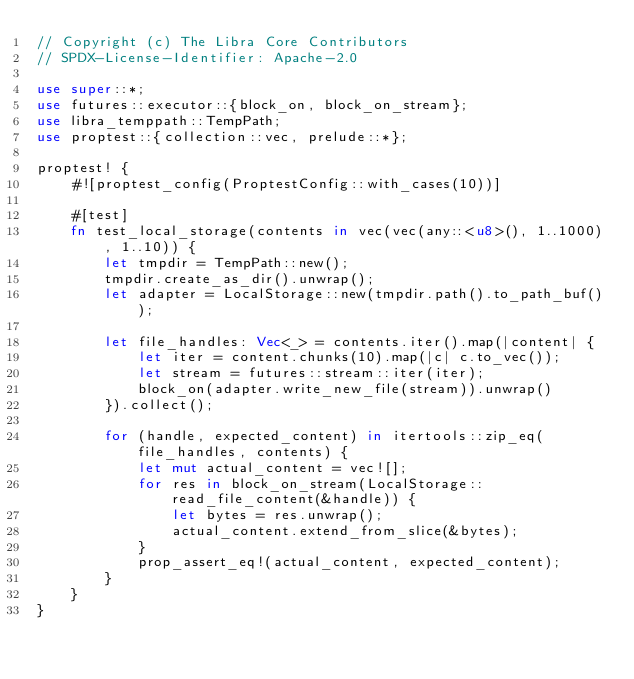Convert code to text. <code><loc_0><loc_0><loc_500><loc_500><_Rust_>// Copyright (c) The Libra Core Contributors
// SPDX-License-Identifier: Apache-2.0

use super::*;
use futures::executor::{block_on, block_on_stream};
use libra_temppath::TempPath;
use proptest::{collection::vec, prelude::*};

proptest! {
    #![proptest_config(ProptestConfig::with_cases(10))]

    #[test]
    fn test_local_storage(contents in vec(vec(any::<u8>(), 1..1000), 1..10)) {
        let tmpdir = TempPath::new();
        tmpdir.create_as_dir().unwrap();
        let adapter = LocalStorage::new(tmpdir.path().to_path_buf());

        let file_handles: Vec<_> = contents.iter().map(|content| {
            let iter = content.chunks(10).map(|c| c.to_vec());
            let stream = futures::stream::iter(iter);
            block_on(adapter.write_new_file(stream)).unwrap()
        }).collect();

        for (handle, expected_content) in itertools::zip_eq(file_handles, contents) {
            let mut actual_content = vec![];
            for res in block_on_stream(LocalStorage::read_file_content(&handle)) {
                let bytes = res.unwrap();
                actual_content.extend_from_slice(&bytes);
            }
            prop_assert_eq!(actual_content, expected_content);
        }
    }
}
</code> 